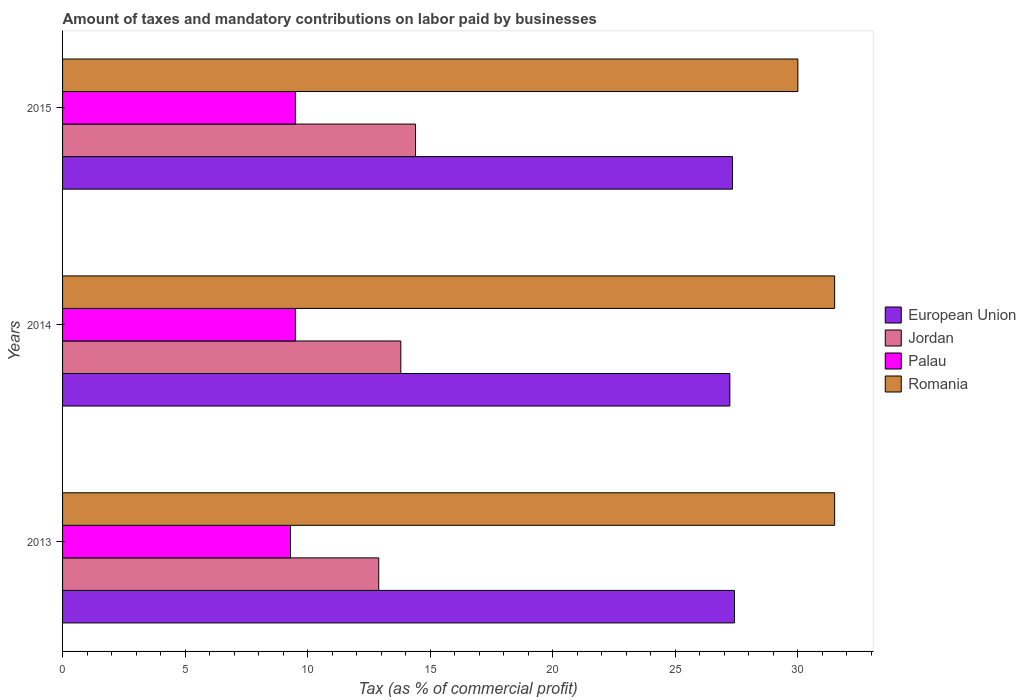Are the number of bars on each tick of the Y-axis equal?
Your response must be concise. Yes. What is the percentage of taxes paid by businesses in European Union in 2013?
Provide a succinct answer. 27.41. Across all years, what is the maximum percentage of taxes paid by businesses in Palau?
Provide a succinct answer. 9.5. Across all years, what is the minimum percentage of taxes paid by businesses in European Union?
Offer a terse response. 27.23. In which year was the percentage of taxes paid by businesses in Romania minimum?
Your answer should be compact. 2015. What is the total percentage of taxes paid by businesses in Romania in the graph?
Provide a succinct answer. 93. What is the difference between the percentage of taxes paid by businesses in European Union in 2014 and the percentage of taxes paid by businesses in Jordan in 2015?
Keep it short and to the point. 12.83. In the year 2014, what is the difference between the percentage of taxes paid by businesses in Palau and percentage of taxes paid by businesses in Jordan?
Offer a terse response. -4.3. What is the ratio of the percentage of taxes paid by businesses in Palau in 2013 to that in 2015?
Offer a terse response. 0.98. In how many years, is the percentage of taxes paid by businesses in Jordan greater than the average percentage of taxes paid by businesses in Jordan taken over all years?
Your answer should be compact. 2. Is the sum of the percentage of taxes paid by businesses in Palau in 2013 and 2014 greater than the maximum percentage of taxes paid by businesses in Jordan across all years?
Your answer should be very brief. Yes. Is it the case that in every year, the sum of the percentage of taxes paid by businesses in European Union and percentage of taxes paid by businesses in Romania is greater than the sum of percentage of taxes paid by businesses in Jordan and percentage of taxes paid by businesses in Palau?
Offer a terse response. Yes. What does the 3rd bar from the top in 2013 represents?
Your answer should be compact. Jordan. Are all the bars in the graph horizontal?
Give a very brief answer. Yes. How many years are there in the graph?
Your answer should be very brief. 3. Does the graph contain any zero values?
Your response must be concise. No. Where does the legend appear in the graph?
Ensure brevity in your answer.  Center right. How many legend labels are there?
Your answer should be very brief. 4. What is the title of the graph?
Your answer should be very brief. Amount of taxes and mandatory contributions on labor paid by businesses. Does "Georgia" appear as one of the legend labels in the graph?
Your response must be concise. No. What is the label or title of the X-axis?
Keep it short and to the point. Tax (as % of commercial profit). What is the Tax (as % of commercial profit) of European Union in 2013?
Make the answer very short. 27.41. What is the Tax (as % of commercial profit) of Jordan in 2013?
Your answer should be compact. 12.9. What is the Tax (as % of commercial profit) of Palau in 2013?
Offer a very short reply. 9.3. What is the Tax (as % of commercial profit) in Romania in 2013?
Provide a succinct answer. 31.5. What is the Tax (as % of commercial profit) of European Union in 2014?
Provide a succinct answer. 27.23. What is the Tax (as % of commercial profit) in Romania in 2014?
Your response must be concise. 31.5. What is the Tax (as % of commercial profit) of European Union in 2015?
Make the answer very short. 27.33. Across all years, what is the maximum Tax (as % of commercial profit) in European Union?
Make the answer very short. 27.41. Across all years, what is the maximum Tax (as % of commercial profit) of Romania?
Ensure brevity in your answer.  31.5. Across all years, what is the minimum Tax (as % of commercial profit) in European Union?
Provide a short and direct response. 27.23. Across all years, what is the minimum Tax (as % of commercial profit) in Jordan?
Ensure brevity in your answer.  12.9. Across all years, what is the minimum Tax (as % of commercial profit) of Romania?
Provide a short and direct response. 30. What is the total Tax (as % of commercial profit) of European Union in the graph?
Give a very brief answer. 81.97. What is the total Tax (as % of commercial profit) of Jordan in the graph?
Provide a short and direct response. 41.1. What is the total Tax (as % of commercial profit) in Palau in the graph?
Ensure brevity in your answer.  28.3. What is the total Tax (as % of commercial profit) in Romania in the graph?
Keep it short and to the point. 93. What is the difference between the Tax (as % of commercial profit) in European Union in 2013 and that in 2014?
Provide a short and direct response. 0.19. What is the difference between the Tax (as % of commercial profit) in Romania in 2013 and that in 2014?
Provide a succinct answer. 0. What is the difference between the Tax (as % of commercial profit) of European Union in 2013 and that in 2015?
Offer a very short reply. 0.08. What is the difference between the Tax (as % of commercial profit) in Palau in 2013 and that in 2015?
Offer a terse response. -0.2. What is the difference between the Tax (as % of commercial profit) in Romania in 2013 and that in 2015?
Make the answer very short. 1.5. What is the difference between the Tax (as % of commercial profit) in European Union in 2014 and that in 2015?
Your answer should be compact. -0.11. What is the difference between the Tax (as % of commercial profit) in Palau in 2014 and that in 2015?
Ensure brevity in your answer.  0. What is the difference between the Tax (as % of commercial profit) in European Union in 2013 and the Tax (as % of commercial profit) in Jordan in 2014?
Your answer should be compact. 13.61. What is the difference between the Tax (as % of commercial profit) of European Union in 2013 and the Tax (as % of commercial profit) of Palau in 2014?
Your answer should be compact. 17.91. What is the difference between the Tax (as % of commercial profit) of European Union in 2013 and the Tax (as % of commercial profit) of Romania in 2014?
Your answer should be compact. -4.09. What is the difference between the Tax (as % of commercial profit) of Jordan in 2013 and the Tax (as % of commercial profit) of Romania in 2014?
Your answer should be very brief. -18.6. What is the difference between the Tax (as % of commercial profit) in Palau in 2013 and the Tax (as % of commercial profit) in Romania in 2014?
Offer a terse response. -22.2. What is the difference between the Tax (as % of commercial profit) of European Union in 2013 and the Tax (as % of commercial profit) of Jordan in 2015?
Provide a short and direct response. 13.01. What is the difference between the Tax (as % of commercial profit) in European Union in 2013 and the Tax (as % of commercial profit) in Palau in 2015?
Provide a succinct answer. 17.91. What is the difference between the Tax (as % of commercial profit) in European Union in 2013 and the Tax (as % of commercial profit) in Romania in 2015?
Your answer should be very brief. -2.59. What is the difference between the Tax (as % of commercial profit) of Jordan in 2013 and the Tax (as % of commercial profit) of Palau in 2015?
Your answer should be very brief. 3.4. What is the difference between the Tax (as % of commercial profit) of Jordan in 2013 and the Tax (as % of commercial profit) of Romania in 2015?
Make the answer very short. -17.1. What is the difference between the Tax (as % of commercial profit) in Palau in 2013 and the Tax (as % of commercial profit) in Romania in 2015?
Offer a very short reply. -20.7. What is the difference between the Tax (as % of commercial profit) of European Union in 2014 and the Tax (as % of commercial profit) of Jordan in 2015?
Your answer should be very brief. 12.82. What is the difference between the Tax (as % of commercial profit) of European Union in 2014 and the Tax (as % of commercial profit) of Palau in 2015?
Give a very brief answer. 17.73. What is the difference between the Tax (as % of commercial profit) of European Union in 2014 and the Tax (as % of commercial profit) of Romania in 2015?
Make the answer very short. -2.77. What is the difference between the Tax (as % of commercial profit) in Jordan in 2014 and the Tax (as % of commercial profit) in Romania in 2015?
Your response must be concise. -16.2. What is the difference between the Tax (as % of commercial profit) of Palau in 2014 and the Tax (as % of commercial profit) of Romania in 2015?
Make the answer very short. -20.5. What is the average Tax (as % of commercial profit) of European Union per year?
Offer a very short reply. 27.32. What is the average Tax (as % of commercial profit) of Palau per year?
Your response must be concise. 9.43. In the year 2013, what is the difference between the Tax (as % of commercial profit) of European Union and Tax (as % of commercial profit) of Jordan?
Make the answer very short. 14.51. In the year 2013, what is the difference between the Tax (as % of commercial profit) of European Union and Tax (as % of commercial profit) of Palau?
Offer a very short reply. 18.11. In the year 2013, what is the difference between the Tax (as % of commercial profit) of European Union and Tax (as % of commercial profit) of Romania?
Your response must be concise. -4.09. In the year 2013, what is the difference between the Tax (as % of commercial profit) in Jordan and Tax (as % of commercial profit) in Palau?
Offer a terse response. 3.6. In the year 2013, what is the difference between the Tax (as % of commercial profit) in Jordan and Tax (as % of commercial profit) in Romania?
Ensure brevity in your answer.  -18.6. In the year 2013, what is the difference between the Tax (as % of commercial profit) in Palau and Tax (as % of commercial profit) in Romania?
Provide a short and direct response. -22.2. In the year 2014, what is the difference between the Tax (as % of commercial profit) in European Union and Tax (as % of commercial profit) in Jordan?
Your answer should be compact. 13.43. In the year 2014, what is the difference between the Tax (as % of commercial profit) of European Union and Tax (as % of commercial profit) of Palau?
Make the answer very short. 17.73. In the year 2014, what is the difference between the Tax (as % of commercial profit) in European Union and Tax (as % of commercial profit) in Romania?
Give a very brief answer. -4.28. In the year 2014, what is the difference between the Tax (as % of commercial profit) in Jordan and Tax (as % of commercial profit) in Palau?
Give a very brief answer. 4.3. In the year 2014, what is the difference between the Tax (as % of commercial profit) in Jordan and Tax (as % of commercial profit) in Romania?
Make the answer very short. -17.7. In the year 2015, what is the difference between the Tax (as % of commercial profit) in European Union and Tax (as % of commercial profit) in Jordan?
Make the answer very short. 12.93. In the year 2015, what is the difference between the Tax (as % of commercial profit) of European Union and Tax (as % of commercial profit) of Palau?
Offer a terse response. 17.83. In the year 2015, what is the difference between the Tax (as % of commercial profit) in European Union and Tax (as % of commercial profit) in Romania?
Offer a very short reply. -2.67. In the year 2015, what is the difference between the Tax (as % of commercial profit) in Jordan and Tax (as % of commercial profit) in Romania?
Offer a very short reply. -15.6. In the year 2015, what is the difference between the Tax (as % of commercial profit) in Palau and Tax (as % of commercial profit) in Romania?
Offer a very short reply. -20.5. What is the ratio of the Tax (as % of commercial profit) of European Union in 2013 to that in 2014?
Give a very brief answer. 1.01. What is the ratio of the Tax (as % of commercial profit) in Jordan in 2013 to that in 2014?
Make the answer very short. 0.93. What is the ratio of the Tax (as % of commercial profit) of Palau in 2013 to that in 2014?
Provide a short and direct response. 0.98. What is the ratio of the Tax (as % of commercial profit) of Romania in 2013 to that in 2014?
Your answer should be compact. 1. What is the ratio of the Tax (as % of commercial profit) of Jordan in 2013 to that in 2015?
Offer a terse response. 0.9. What is the ratio of the Tax (as % of commercial profit) of Palau in 2013 to that in 2015?
Offer a very short reply. 0.98. What is the ratio of the Tax (as % of commercial profit) of Jordan in 2014 to that in 2015?
Your answer should be compact. 0.96. What is the difference between the highest and the second highest Tax (as % of commercial profit) of European Union?
Ensure brevity in your answer.  0.08. What is the difference between the highest and the second highest Tax (as % of commercial profit) in Jordan?
Make the answer very short. 0.6. What is the difference between the highest and the second highest Tax (as % of commercial profit) of Palau?
Give a very brief answer. 0. What is the difference between the highest and the lowest Tax (as % of commercial profit) of European Union?
Ensure brevity in your answer.  0.19. What is the difference between the highest and the lowest Tax (as % of commercial profit) of Palau?
Offer a terse response. 0.2. 